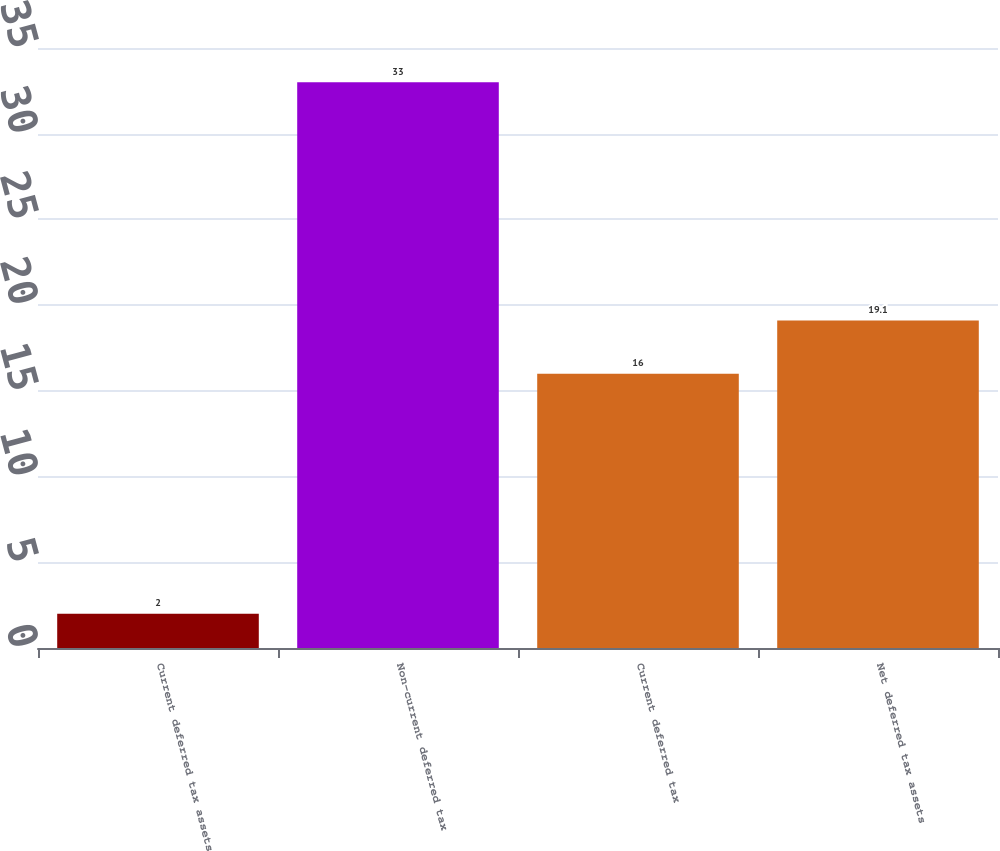Convert chart to OTSL. <chart><loc_0><loc_0><loc_500><loc_500><bar_chart><fcel>Current deferred tax assets<fcel>Non-current deferred tax<fcel>Current deferred tax<fcel>Net deferred tax assets<nl><fcel>2<fcel>33<fcel>16<fcel>19.1<nl></chart> 